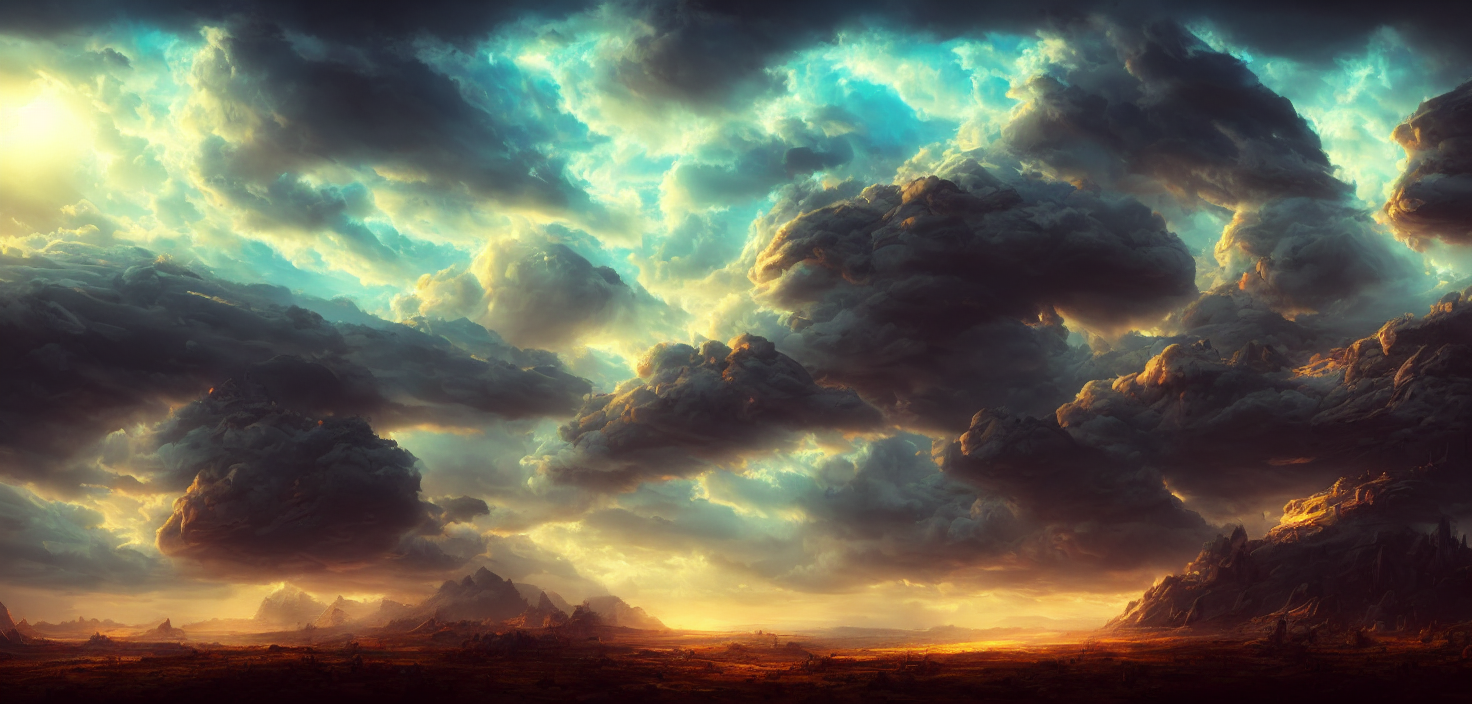What kind of weather do the clouds in the image suggest? The clouds in the image suggest a possible brewing storm. The thickness, darkness, and tumultuous shapes of the clouds imply heaviness and the potential for rain. Additionally, the way that light permeates some parts of the clouds may indicate that the storm is either approaching or clearing, with the sunlight attempting to break through. Can you describe the topography presented and how it adds to the image composition? The image shows a diverse topography with sweeping plains in the foreground transitioning into craggy, towering mountains in the middle and background. These geological forms create a layered composition, with each tier offering a different texture and color palette that draws the viewer's eye deeper into the scene. The contrast between the open, flat terrain and the rugged, vertical mountain peaks adds a dynamic tension to the image, enhancing its overall visual impact. 